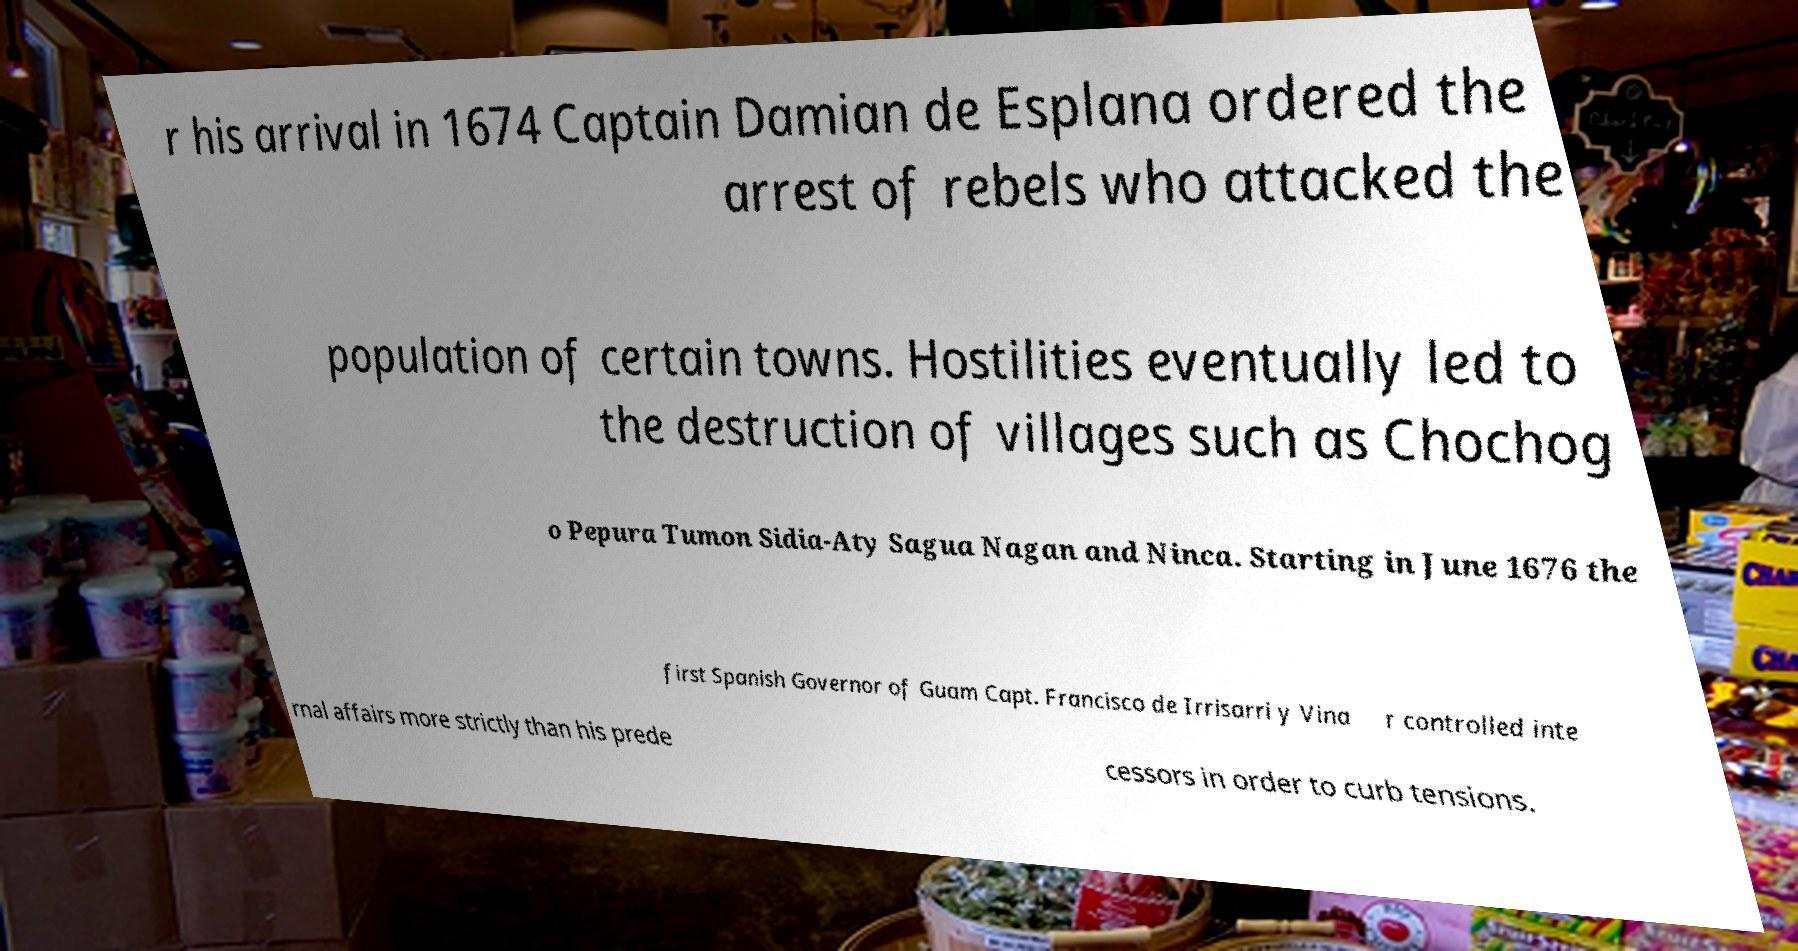Could you extract and type out the text from this image? r his arrival in 1674 Captain Damian de Esplana ordered the arrest of rebels who attacked the population of certain towns. Hostilities eventually led to the destruction of villages such as Chochog o Pepura Tumon Sidia-Aty Sagua Nagan and Ninca. Starting in June 1676 the first Spanish Governor of Guam Capt. Francisco de Irrisarri y Vina r controlled inte rnal affairs more strictly than his prede cessors in order to curb tensions. 